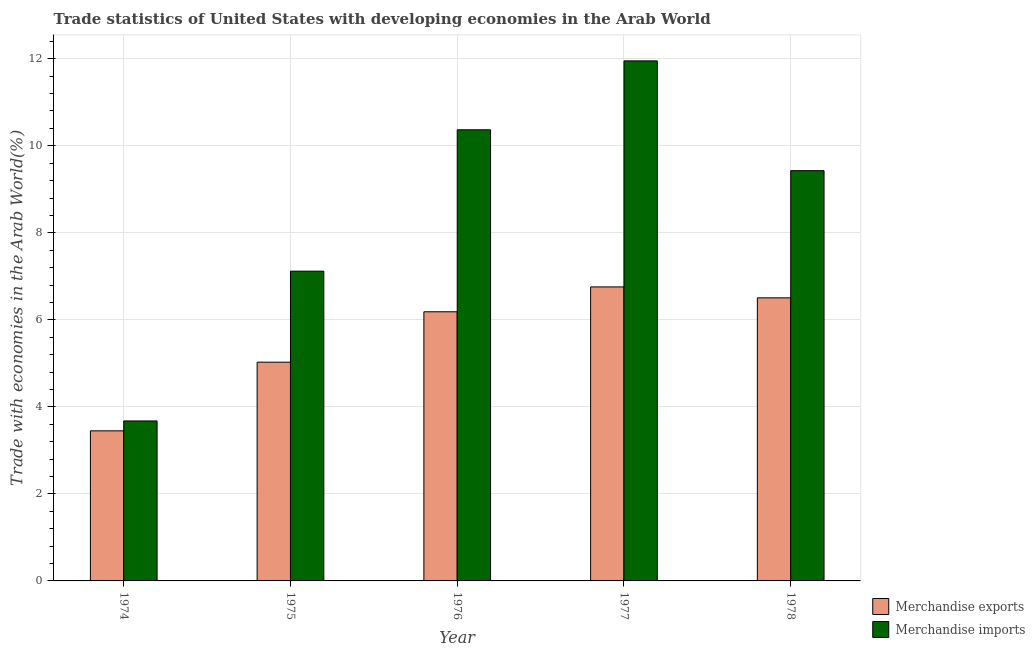What is the label of the 1st group of bars from the left?
Your answer should be compact. 1974. What is the merchandise imports in 1977?
Offer a terse response. 11.95. Across all years, what is the maximum merchandise exports?
Provide a short and direct response. 6.76. Across all years, what is the minimum merchandise imports?
Your response must be concise. 3.68. In which year was the merchandise exports minimum?
Your answer should be compact. 1974. What is the total merchandise exports in the graph?
Your response must be concise. 27.92. What is the difference between the merchandise imports in 1974 and that in 1978?
Ensure brevity in your answer.  -5.75. What is the difference between the merchandise imports in 1977 and the merchandise exports in 1976?
Provide a succinct answer. 1.58. What is the average merchandise exports per year?
Provide a short and direct response. 5.58. In the year 1976, what is the difference between the merchandise imports and merchandise exports?
Ensure brevity in your answer.  0. In how many years, is the merchandise imports greater than 10 %?
Your answer should be compact. 2. What is the ratio of the merchandise imports in 1977 to that in 1978?
Offer a terse response. 1.27. What is the difference between the highest and the second highest merchandise exports?
Make the answer very short. 0.25. What is the difference between the highest and the lowest merchandise imports?
Provide a succinct answer. 8.28. In how many years, is the merchandise imports greater than the average merchandise imports taken over all years?
Provide a short and direct response. 3. What does the 1st bar from the left in 1975 represents?
Keep it short and to the point. Merchandise exports. How many bars are there?
Provide a succinct answer. 10. Are all the bars in the graph horizontal?
Offer a very short reply. No. How many years are there in the graph?
Keep it short and to the point. 5. Are the values on the major ticks of Y-axis written in scientific E-notation?
Provide a succinct answer. No. Does the graph contain any zero values?
Offer a very short reply. No. Where does the legend appear in the graph?
Ensure brevity in your answer.  Bottom right. What is the title of the graph?
Keep it short and to the point. Trade statistics of United States with developing economies in the Arab World. What is the label or title of the Y-axis?
Make the answer very short. Trade with economies in the Arab World(%). What is the Trade with economies in the Arab World(%) in Merchandise exports in 1974?
Provide a short and direct response. 3.45. What is the Trade with economies in the Arab World(%) in Merchandise imports in 1974?
Ensure brevity in your answer.  3.68. What is the Trade with economies in the Arab World(%) of Merchandise exports in 1975?
Make the answer very short. 5.03. What is the Trade with economies in the Arab World(%) of Merchandise imports in 1975?
Your answer should be compact. 7.12. What is the Trade with economies in the Arab World(%) of Merchandise exports in 1976?
Offer a terse response. 6.19. What is the Trade with economies in the Arab World(%) in Merchandise imports in 1976?
Offer a terse response. 10.37. What is the Trade with economies in the Arab World(%) of Merchandise exports in 1977?
Provide a succinct answer. 6.76. What is the Trade with economies in the Arab World(%) in Merchandise imports in 1977?
Offer a very short reply. 11.95. What is the Trade with economies in the Arab World(%) in Merchandise exports in 1978?
Offer a very short reply. 6.51. What is the Trade with economies in the Arab World(%) in Merchandise imports in 1978?
Your answer should be very brief. 9.43. Across all years, what is the maximum Trade with economies in the Arab World(%) of Merchandise exports?
Ensure brevity in your answer.  6.76. Across all years, what is the maximum Trade with economies in the Arab World(%) in Merchandise imports?
Your answer should be very brief. 11.95. Across all years, what is the minimum Trade with economies in the Arab World(%) in Merchandise exports?
Your answer should be very brief. 3.45. Across all years, what is the minimum Trade with economies in the Arab World(%) of Merchandise imports?
Offer a terse response. 3.68. What is the total Trade with economies in the Arab World(%) in Merchandise exports in the graph?
Ensure brevity in your answer.  27.92. What is the total Trade with economies in the Arab World(%) in Merchandise imports in the graph?
Offer a very short reply. 42.54. What is the difference between the Trade with economies in the Arab World(%) of Merchandise exports in 1974 and that in 1975?
Offer a terse response. -1.58. What is the difference between the Trade with economies in the Arab World(%) in Merchandise imports in 1974 and that in 1975?
Your response must be concise. -3.44. What is the difference between the Trade with economies in the Arab World(%) of Merchandise exports in 1974 and that in 1976?
Make the answer very short. -2.74. What is the difference between the Trade with economies in the Arab World(%) of Merchandise imports in 1974 and that in 1976?
Keep it short and to the point. -6.69. What is the difference between the Trade with economies in the Arab World(%) of Merchandise exports in 1974 and that in 1977?
Your answer should be very brief. -3.31. What is the difference between the Trade with economies in the Arab World(%) in Merchandise imports in 1974 and that in 1977?
Provide a short and direct response. -8.28. What is the difference between the Trade with economies in the Arab World(%) of Merchandise exports in 1974 and that in 1978?
Offer a terse response. -3.06. What is the difference between the Trade with economies in the Arab World(%) in Merchandise imports in 1974 and that in 1978?
Offer a very short reply. -5.75. What is the difference between the Trade with economies in the Arab World(%) of Merchandise exports in 1975 and that in 1976?
Give a very brief answer. -1.16. What is the difference between the Trade with economies in the Arab World(%) in Merchandise imports in 1975 and that in 1976?
Give a very brief answer. -3.25. What is the difference between the Trade with economies in the Arab World(%) of Merchandise exports in 1975 and that in 1977?
Give a very brief answer. -1.73. What is the difference between the Trade with economies in the Arab World(%) in Merchandise imports in 1975 and that in 1977?
Keep it short and to the point. -4.83. What is the difference between the Trade with economies in the Arab World(%) of Merchandise exports in 1975 and that in 1978?
Make the answer very short. -1.48. What is the difference between the Trade with economies in the Arab World(%) of Merchandise imports in 1975 and that in 1978?
Offer a terse response. -2.31. What is the difference between the Trade with economies in the Arab World(%) of Merchandise exports in 1976 and that in 1977?
Your answer should be compact. -0.57. What is the difference between the Trade with economies in the Arab World(%) in Merchandise imports in 1976 and that in 1977?
Make the answer very short. -1.58. What is the difference between the Trade with economies in the Arab World(%) of Merchandise exports in 1976 and that in 1978?
Offer a very short reply. -0.32. What is the difference between the Trade with economies in the Arab World(%) of Merchandise imports in 1976 and that in 1978?
Provide a short and direct response. 0.94. What is the difference between the Trade with economies in the Arab World(%) of Merchandise exports in 1977 and that in 1978?
Provide a succinct answer. 0.25. What is the difference between the Trade with economies in the Arab World(%) of Merchandise imports in 1977 and that in 1978?
Offer a very short reply. 2.52. What is the difference between the Trade with economies in the Arab World(%) in Merchandise exports in 1974 and the Trade with economies in the Arab World(%) in Merchandise imports in 1975?
Provide a short and direct response. -3.67. What is the difference between the Trade with economies in the Arab World(%) in Merchandise exports in 1974 and the Trade with economies in the Arab World(%) in Merchandise imports in 1976?
Offer a terse response. -6.92. What is the difference between the Trade with economies in the Arab World(%) of Merchandise exports in 1974 and the Trade with economies in the Arab World(%) of Merchandise imports in 1977?
Give a very brief answer. -8.5. What is the difference between the Trade with economies in the Arab World(%) of Merchandise exports in 1974 and the Trade with economies in the Arab World(%) of Merchandise imports in 1978?
Offer a very short reply. -5.98. What is the difference between the Trade with economies in the Arab World(%) of Merchandise exports in 1975 and the Trade with economies in the Arab World(%) of Merchandise imports in 1976?
Provide a short and direct response. -5.34. What is the difference between the Trade with economies in the Arab World(%) of Merchandise exports in 1975 and the Trade with economies in the Arab World(%) of Merchandise imports in 1977?
Provide a succinct answer. -6.92. What is the difference between the Trade with economies in the Arab World(%) in Merchandise exports in 1975 and the Trade with economies in the Arab World(%) in Merchandise imports in 1978?
Keep it short and to the point. -4.4. What is the difference between the Trade with economies in the Arab World(%) of Merchandise exports in 1976 and the Trade with economies in the Arab World(%) of Merchandise imports in 1977?
Provide a short and direct response. -5.77. What is the difference between the Trade with economies in the Arab World(%) in Merchandise exports in 1976 and the Trade with economies in the Arab World(%) in Merchandise imports in 1978?
Offer a terse response. -3.24. What is the difference between the Trade with economies in the Arab World(%) in Merchandise exports in 1977 and the Trade with economies in the Arab World(%) in Merchandise imports in 1978?
Offer a very short reply. -2.67. What is the average Trade with economies in the Arab World(%) in Merchandise exports per year?
Keep it short and to the point. 5.58. What is the average Trade with economies in the Arab World(%) in Merchandise imports per year?
Your response must be concise. 8.51. In the year 1974, what is the difference between the Trade with economies in the Arab World(%) in Merchandise exports and Trade with economies in the Arab World(%) in Merchandise imports?
Provide a succinct answer. -0.23. In the year 1975, what is the difference between the Trade with economies in the Arab World(%) of Merchandise exports and Trade with economies in the Arab World(%) of Merchandise imports?
Provide a short and direct response. -2.09. In the year 1976, what is the difference between the Trade with economies in the Arab World(%) in Merchandise exports and Trade with economies in the Arab World(%) in Merchandise imports?
Give a very brief answer. -4.18. In the year 1977, what is the difference between the Trade with economies in the Arab World(%) in Merchandise exports and Trade with economies in the Arab World(%) in Merchandise imports?
Your answer should be compact. -5.19. In the year 1978, what is the difference between the Trade with economies in the Arab World(%) of Merchandise exports and Trade with economies in the Arab World(%) of Merchandise imports?
Your answer should be very brief. -2.92. What is the ratio of the Trade with economies in the Arab World(%) in Merchandise exports in 1974 to that in 1975?
Make the answer very short. 0.69. What is the ratio of the Trade with economies in the Arab World(%) in Merchandise imports in 1974 to that in 1975?
Make the answer very short. 0.52. What is the ratio of the Trade with economies in the Arab World(%) in Merchandise exports in 1974 to that in 1976?
Provide a succinct answer. 0.56. What is the ratio of the Trade with economies in the Arab World(%) in Merchandise imports in 1974 to that in 1976?
Offer a terse response. 0.35. What is the ratio of the Trade with economies in the Arab World(%) of Merchandise exports in 1974 to that in 1977?
Ensure brevity in your answer.  0.51. What is the ratio of the Trade with economies in the Arab World(%) in Merchandise imports in 1974 to that in 1977?
Offer a very short reply. 0.31. What is the ratio of the Trade with economies in the Arab World(%) in Merchandise exports in 1974 to that in 1978?
Keep it short and to the point. 0.53. What is the ratio of the Trade with economies in the Arab World(%) of Merchandise imports in 1974 to that in 1978?
Your answer should be compact. 0.39. What is the ratio of the Trade with economies in the Arab World(%) in Merchandise exports in 1975 to that in 1976?
Ensure brevity in your answer.  0.81. What is the ratio of the Trade with economies in the Arab World(%) of Merchandise imports in 1975 to that in 1976?
Give a very brief answer. 0.69. What is the ratio of the Trade with economies in the Arab World(%) of Merchandise exports in 1975 to that in 1977?
Make the answer very short. 0.74. What is the ratio of the Trade with economies in the Arab World(%) of Merchandise imports in 1975 to that in 1977?
Provide a succinct answer. 0.6. What is the ratio of the Trade with economies in the Arab World(%) in Merchandise exports in 1975 to that in 1978?
Provide a short and direct response. 0.77. What is the ratio of the Trade with economies in the Arab World(%) of Merchandise imports in 1975 to that in 1978?
Your answer should be compact. 0.76. What is the ratio of the Trade with economies in the Arab World(%) of Merchandise exports in 1976 to that in 1977?
Offer a very short reply. 0.92. What is the ratio of the Trade with economies in the Arab World(%) of Merchandise imports in 1976 to that in 1977?
Ensure brevity in your answer.  0.87. What is the ratio of the Trade with economies in the Arab World(%) of Merchandise exports in 1976 to that in 1978?
Offer a very short reply. 0.95. What is the ratio of the Trade with economies in the Arab World(%) in Merchandise imports in 1976 to that in 1978?
Keep it short and to the point. 1.1. What is the ratio of the Trade with economies in the Arab World(%) in Merchandise exports in 1977 to that in 1978?
Your answer should be very brief. 1.04. What is the ratio of the Trade with economies in the Arab World(%) of Merchandise imports in 1977 to that in 1978?
Ensure brevity in your answer.  1.27. What is the difference between the highest and the second highest Trade with economies in the Arab World(%) in Merchandise exports?
Your response must be concise. 0.25. What is the difference between the highest and the second highest Trade with economies in the Arab World(%) of Merchandise imports?
Offer a very short reply. 1.58. What is the difference between the highest and the lowest Trade with economies in the Arab World(%) in Merchandise exports?
Provide a short and direct response. 3.31. What is the difference between the highest and the lowest Trade with economies in the Arab World(%) of Merchandise imports?
Offer a terse response. 8.28. 